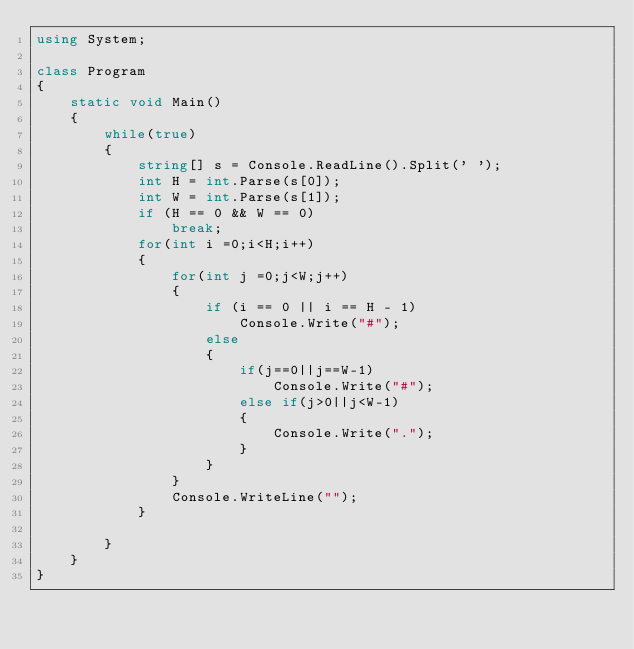Convert code to text. <code><loc_0><loc_0><loc_500><loc_500><_C#_>using System;

class Program
{
    static void Main()
    {
        while(true)
        {
            string[] s = Console.ReadLine().Split(' ');
            int H = int.Parse(s[0]);
            int W = int.Parse(s[1]);
            if (H == 0 && W == 0)
                break;
            for(int i =0;i<H;i++)
            {
                for(int j =0;j<W;j++)
                {
                    if (i == 0 || i == H - 1)
                        Console.Write("#");
                    else
                    {
                        if(j==0||j==W-1)
                            Console.Write("#");
                        else if(j>0||j<W-1)
                        {
                            Console.Write(".");
                        }
                    }
                }
                Console.WriteLine("");
            }

        }
    }
}</code> 